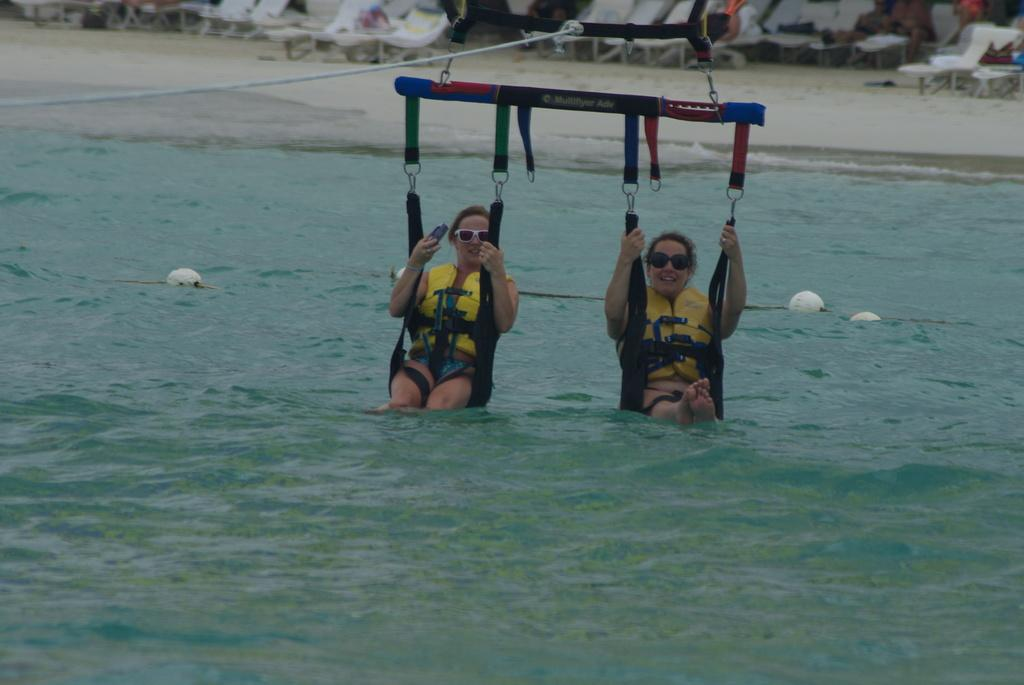How many people are in the image? There are two people in the image. What are the people doing in the image? The people are doing an adventure sport on the sea. What type of furniture can be seen in the image? There are chairs visible in the image. Can you describe any other objects in the image? There are a few other objects in the image, but their specific details are not mentioned in the provided facts. What type of trade is being conducted in the image? There is no indication of any trade being conducted in the image; it features two people doing an adventure sport on the sea. Is there a crook present in the image? There is no mention of a crook or any criminal activity in the image; it features two people doing an adventure sport on the sea. 